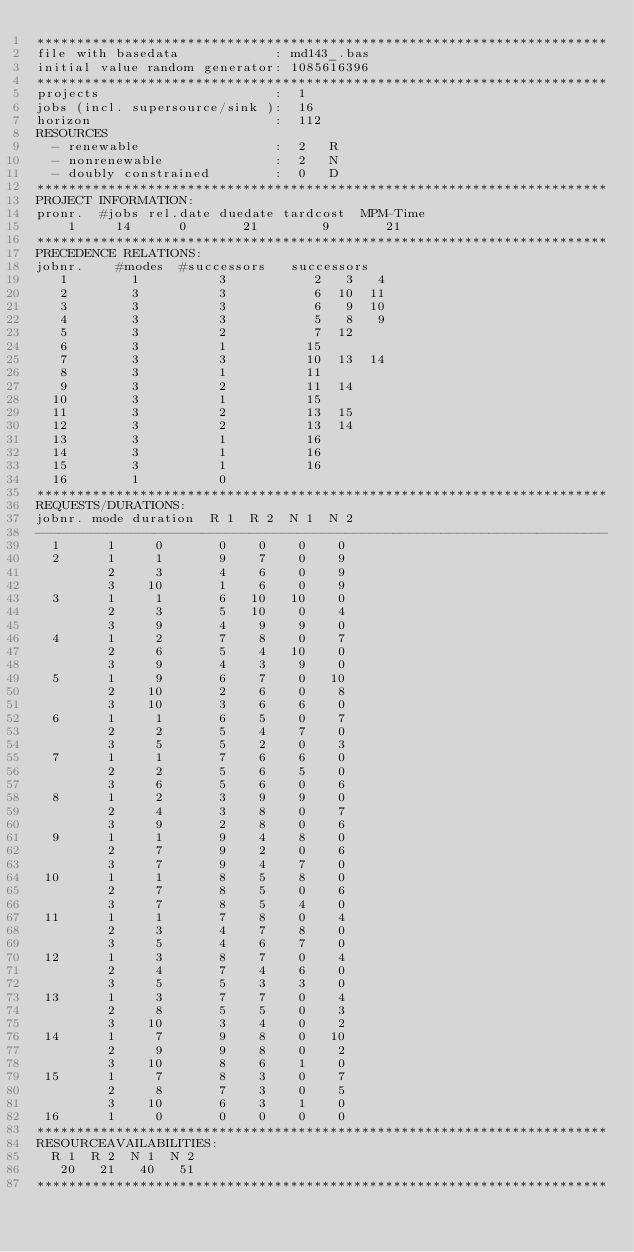<code> <loc_0><loc_0><loc_500><loc_500><_ObjectiveC_>************************************************************************
file with basedata            : md143_.bas
initial value random generator: 1085616396
************************************************************************
projects                      :  1
jobs (incl. supersource/sink ):  16
horizon                       :  112
RESOURCES
  - renewable                 :  2   R
  - nonrenewable              :  2   N
  - doubly constrained        :  0   D
************************************************************************
PROJECT INFORMATION:
pronr.  #jobs rel.date duedate tardcost  MPM-Time
    1     14      0       21        9       21
************************************************************************
PRECEDENCE RELATIONS:
jobnr.    #modes  #successors   successors
   1        1          3           2   3   4
   2        3          3           6  10  11
   3        3          3           6   9  10
   4        3          3           5   8   9
   5        3          2           7  12
   6        3          1          15
   7        3          3          10  13  14
   8        3          1          11
   9        3          2          11  14
  10        3          1          15
  11        3          2          13  15
  12        3          2          13  14
  13        3          1          16
  14        3          1          16
  15        3          1          16
  16        1          0        
************************************************************************
REQUESTS/DURATIONS:
jobnr. mode duration  R 1  R 2  N 1  N 2
------------------------------------------------------------------------
  1      1     0       0    0    0    0
  2      1     1       9    7    0    9
         2     3       4    6    0    9
         3    10       1    6    0    9
  3      1     1       6   10   10    0
         2     3       5   10    0    4
         3     9       4    9    9    0
  4      1     2       7    8    0    7
         2     6       5    4   10    0
         3     9       4    3    9    0
  5      1     9       6    7    0   10
         2    10       2    6    0    8
         3    10       3    6    6    0
  6      1     1       6    5    0    7
         2     2       5    4    7    0
         3     5       5    2    0    3
  7      1     1       7    6    6    0
         2     2       5    6    5    0
         3     6       5    6    0    6
  8      1     2       3    9    9    0
         2     4       3    8    0    7
         3     9       2    8    0    6
  9      1     1       9    4    8    0
         2     7       9    2    0    6
         3     7       9    4    7    0
 10      1     1       8    5    8    0
         2     7       8    5    0    6
         3     7       8    5    4    0
 11      1     1       7    8    0    4
         2     3       4    7    8    0
         3     5       4    6    7    0
 12      1     3       8    7    0    4
         2     4       7    4    6    0
         3     5       5    3    3    0
 13      1     3       7    7    0    4
         2     8       5    5    0    3
         3    10       3    4    0    2
 14      1     7       9    8    0   10
         2     9       9    8    0    2
         3    10       8    6    1    0
 15      1     7       8    3    0    7
         2     8       7    3    0    5
         3    10       6    3    1    0
 16      1     0       0    0    0    0
************************************************************************
RESOURCEAVAILABILITIES:
  R 1  R 2  N 1  N 2
   20   21   40   51
************************************************************************
</code> 